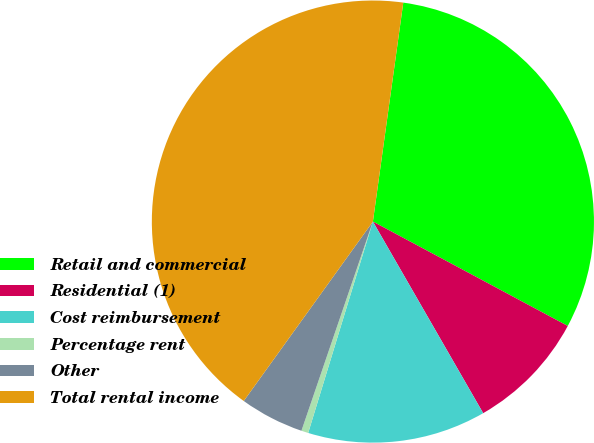<chart> <loc_0><loc_0><loc_500><loc_500><pie_chart><fcel>Retail and commercial<fcel>Residential (1)<fcel>Cost reimbursement<fcel>Percentage rent<fcel>Other<fcel>Total rental income<nl><fcel>30.63%<fcel>8.86%<fcel>13.04%<fcel>0.51%<fcel>4.69%<fcel>42.26%<nl></chart> 